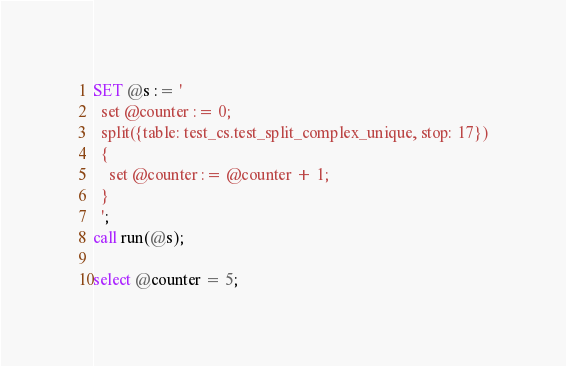<code> <loc_0><loc_0><loc_500><loc_500><_SQL_>
SET @s := '
  set @counter := 0;
  split({table: test_cs.test_split_complex_unique, stop: 17})
  {
    set @counter := @counter + 1;
  }
  ';
call run(@s);

select @counter = 5;

</code> 